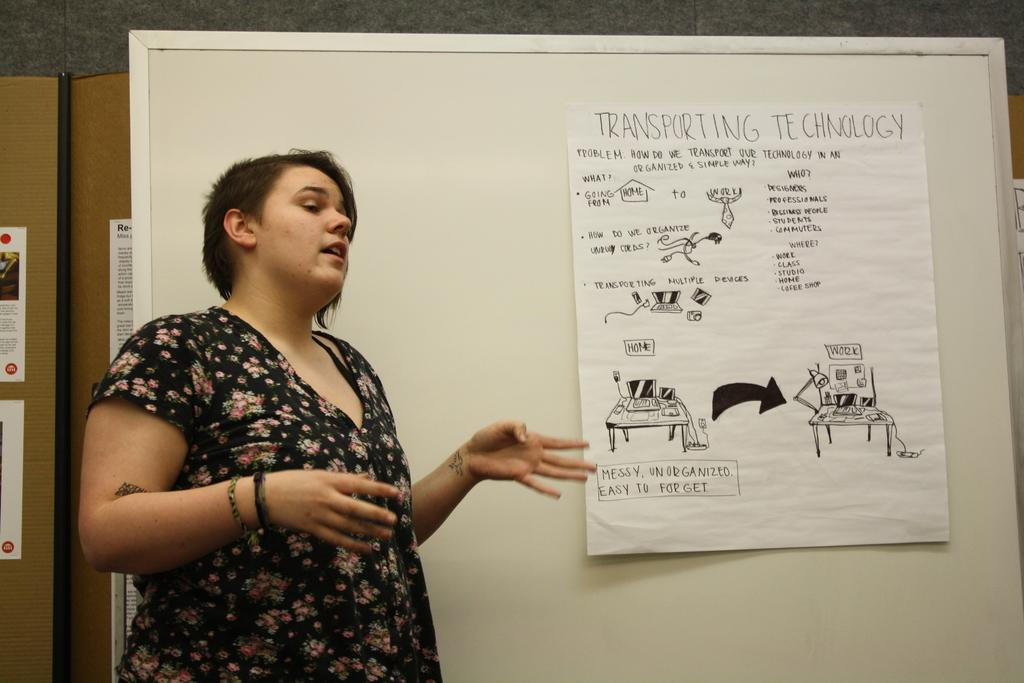What is the main subject of the image? There is a woman standing in the image. What is the woman doing in the image? The woman is talking. What can be seen in the background of the image? There is a board in the image, and it has a poster on it. What is on the poster? The poster contains pictures and text. What type of flesh can be seen on the woman's face in the image? There is no mention of any flesh or skin condition on the woman's face in the image. What card game is being played in the image? There is no card game or any cards visible in the image. 